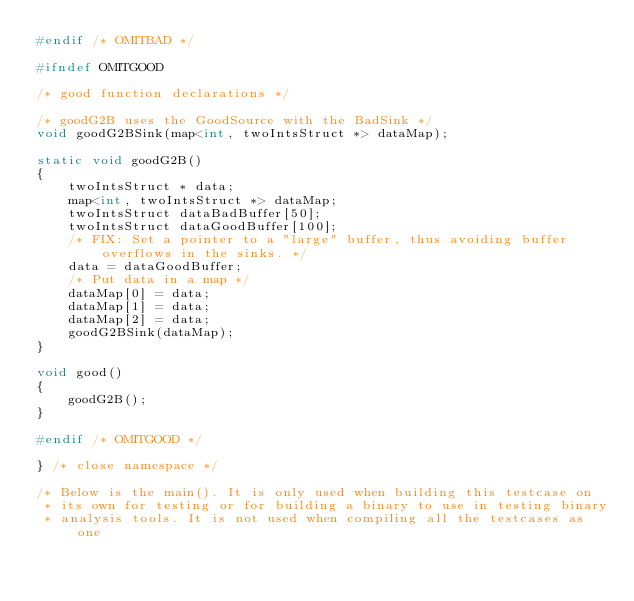Convert code to text. <code><loc_0><loc_0><loc_500><loc_500><_C++_>#endif /* OMITBAD */

#ifndef OMITGOOD

/* good function declarations */

/* goodG2B uses the GoodSource with the BadSink */
void goodG2BSink(map<int, twoIntsStruct *> dataMap);

static void goodG2B()
{
    twoIntsStruct * data;
    map<int, twoIntsStruct *> dataMap;
    twoIntsStruct dataBadBuffer[50];
    twoIntsStruct dataGoodBuffer[100];
    /* FIX: Set a pointer to a "large" buffer, thus avoiding buffer overflows in the sinks. */
    data = dataGoodBuffer;
    /* Put data in a map */
    dataMap[0] = data;
    dataMap[1] = data;
    dataMap[2] = data;
    goodG2BSink(dataMap);
}

void good()
{
    goodG2B();
}

#endif /* OMITGOOD */

} /* close namespace */

/* Below is the main(). It is only used when building this testcase on
 * its own for testing or for building a binary to use in testing binary
 * analysis tools. It is not used when compiling all the testcases as one</code> 